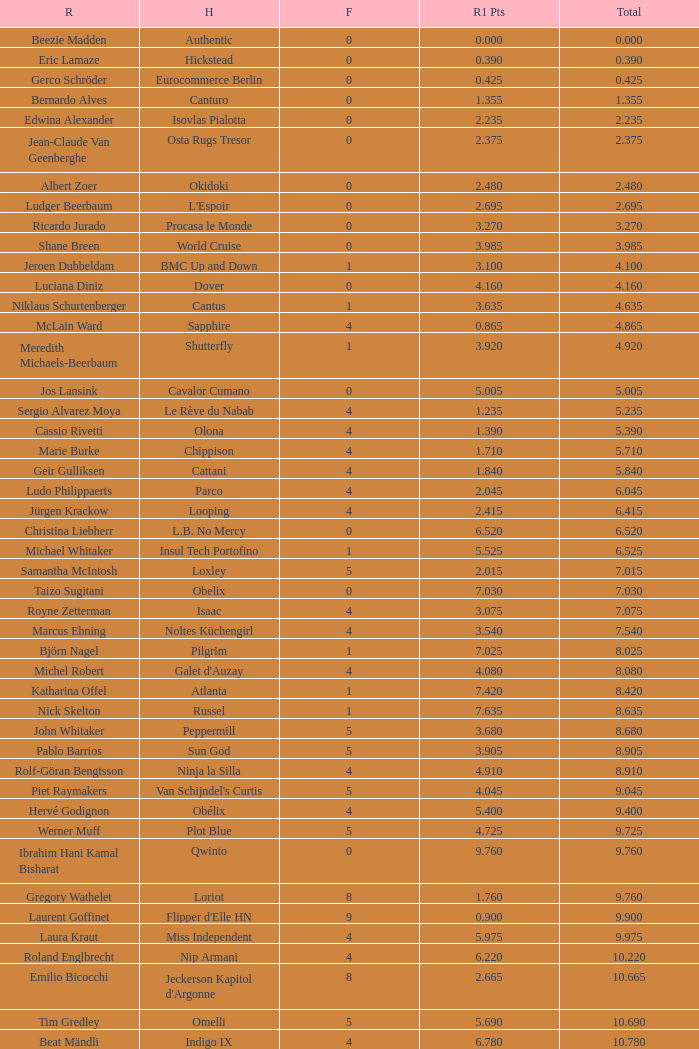Tell me the most total for horse of carlson 29.545. 